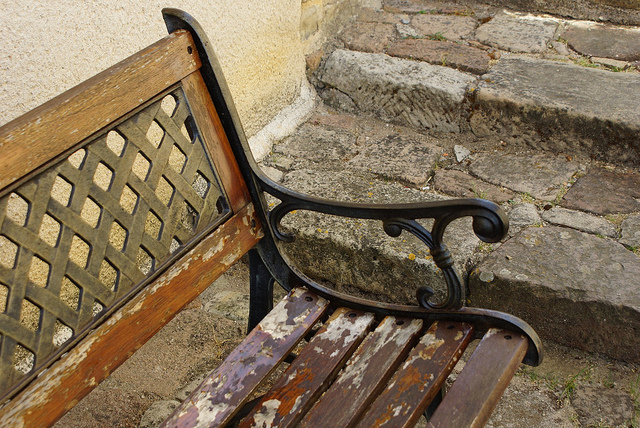What time of day does the lighting suggest the photo was taken? The soft, diffused light and the absence of long shadows suggest the photo was likely taken on an overcast day or when the sun was positioned high in the sky, possibly around midday. 